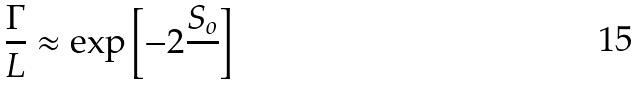Convert formula to latex. <formula><loc_0><loc_0><loc_500><loc_500>\frac { \Gamma } { L } \approx \exp \left [ - 2 \frac { S _ { o } } { } \right ]</formula> 